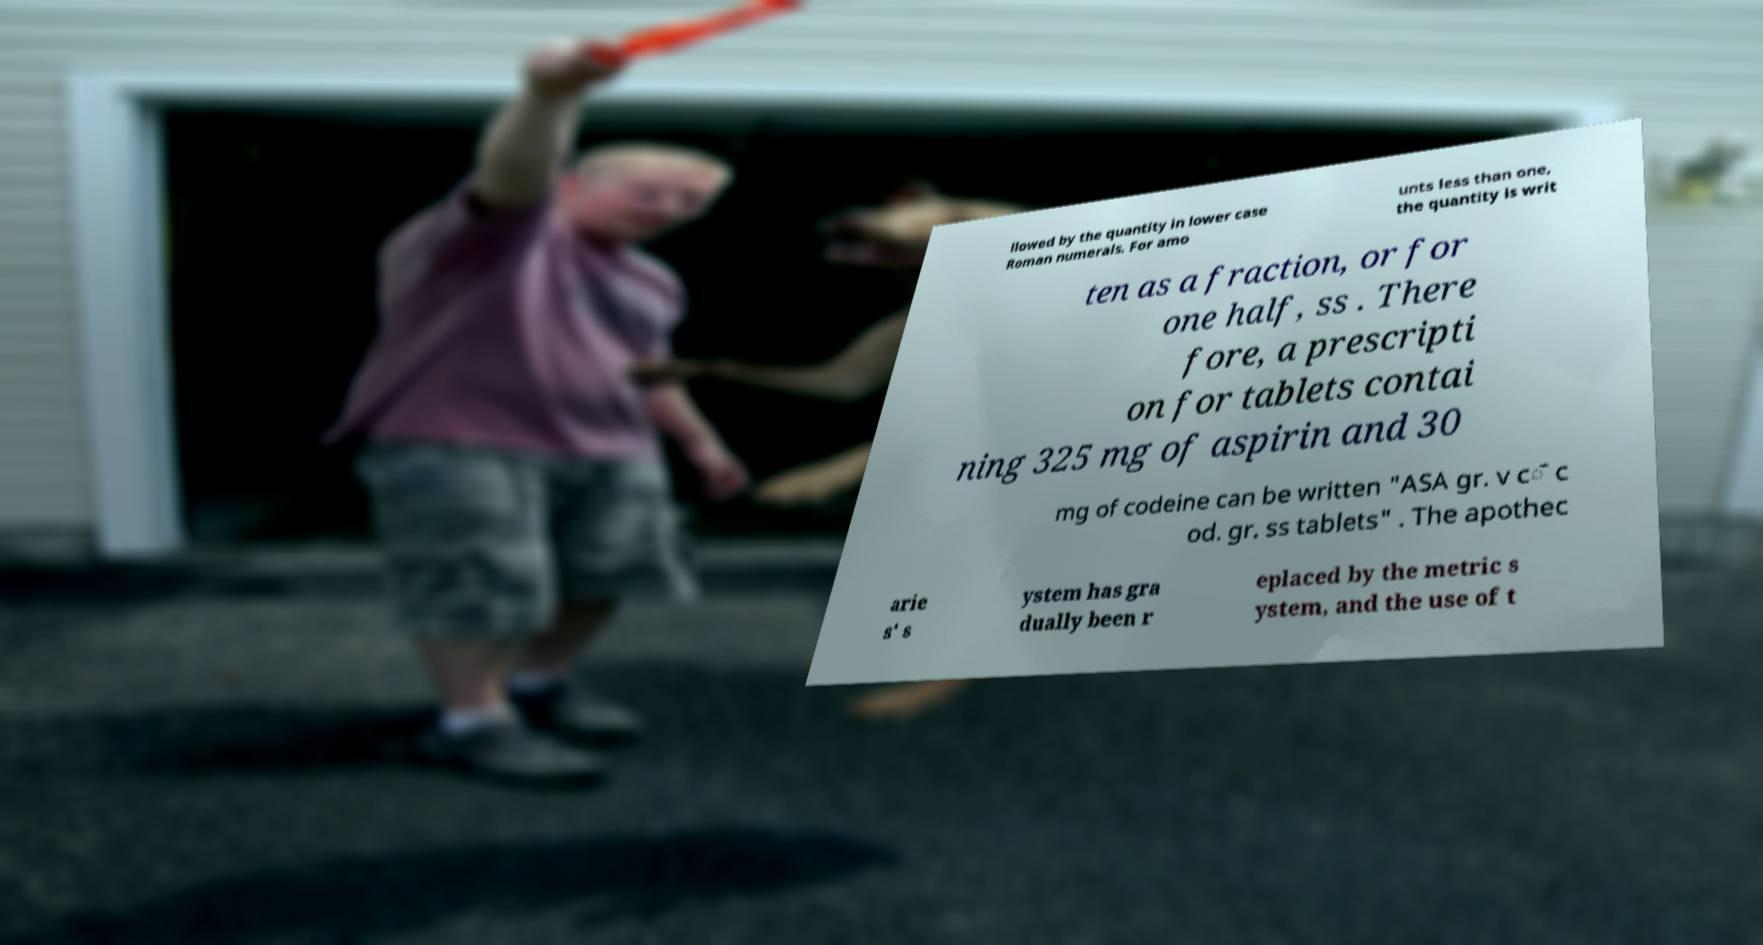What messages or text are displayed in this image? I need them in a readable, typed format. llowed by the quantity in lower case Roman numerals. For amo unts less than one, the quantity is writ ten as a fraction, or for one half, ss . There fore, a prescripti on for tablets contai ning 325 mg of aspirin and 30 mg of codeine can be written "ASA gr. v c̄ c od. gr. ss tablets" . The apothec arie s' s ystem has gra dually been r eplaced by the metric s ystem, and the use of t 